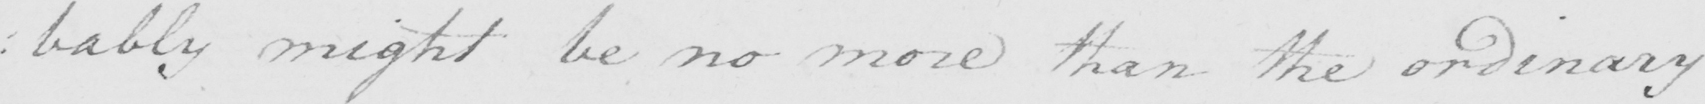Please provide the text content of this handwritten line. : bably might be no more than the ordinary 